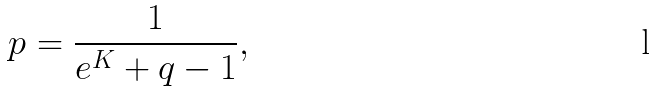Convert formula to latex. <formula><loc_0><loc_0><loc_500><loc_500>p = \frac { 1 } { e ^ { K } + q - 1 } ,</formula> 